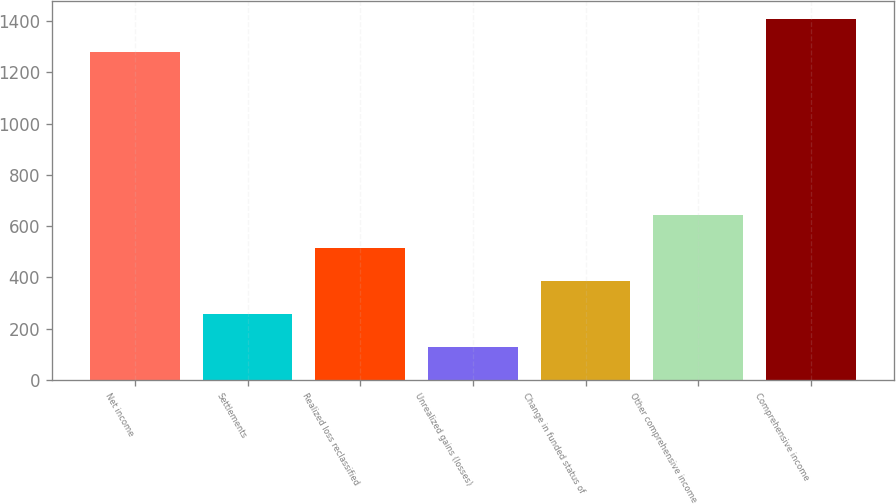<chart> <loc_0><loc_0><loc_500><loc_500><bar_chart><fcel>Net income<fcel>Settlements<fcel>Realized loss reclassified<fcel>Unrealized gains (losses)<fcel>Change in funded status of<fcel>Other comprehensive income<fcel>Comprehensive income<nl><fcel>1279<fcel>257.96<fcel>515.32<fcel>129.28<fcel>386.64<fcel>644<fcel>1407.68<nl></chart> 